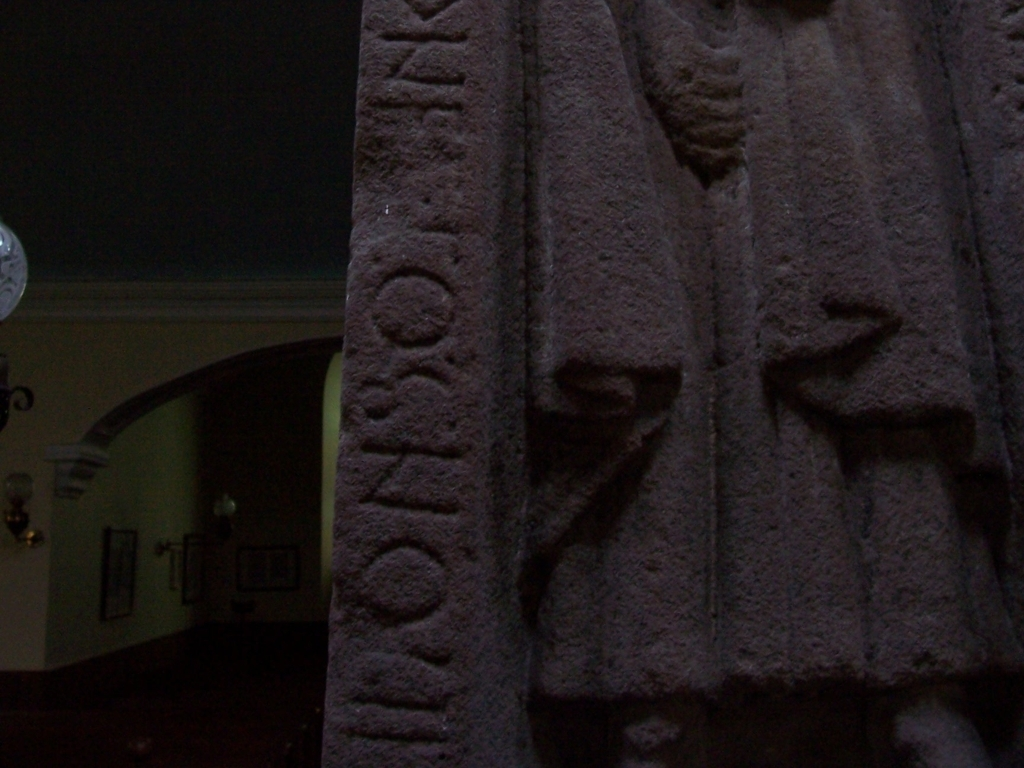The image seems dark and poorly lit. Could there be a reason for this setting? The lighting conditions of the image could very well be intentional if the object is displayed in a museum setting, where subtle lighting is often used to protect delicate artifacts from light damage. Alternatively, the photo might have been taken in a low-light environment such as a historical site or crypt, where natural light is scarce, to maintain the ambiance and authenticity of the surroundings. 